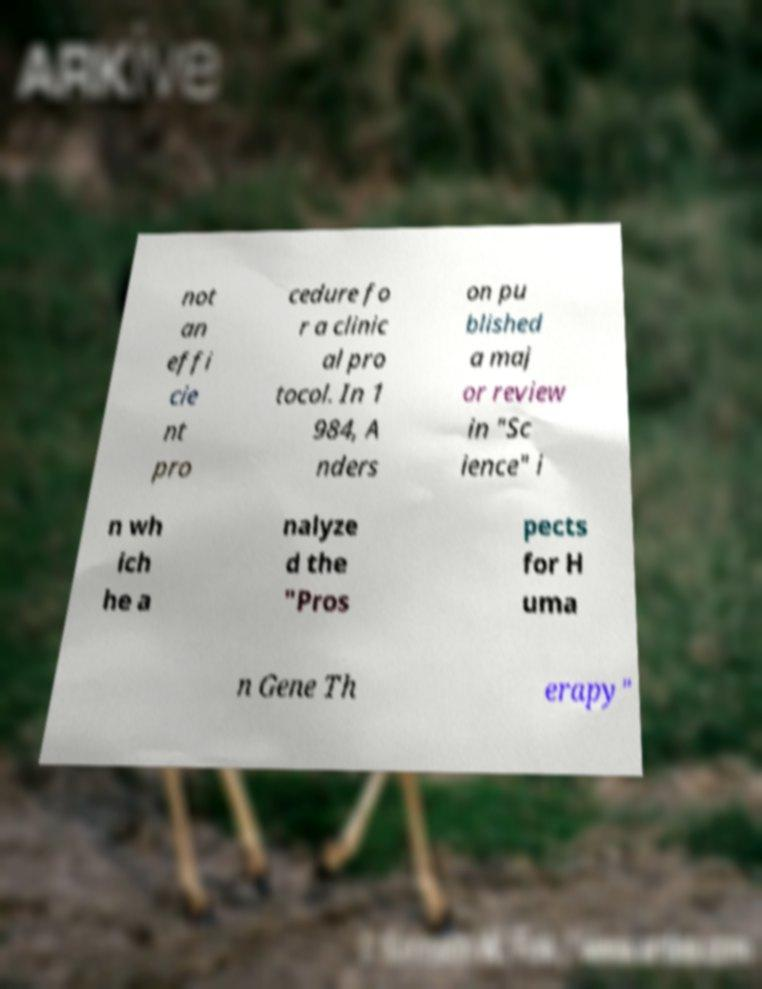There's text embedded in this image that I need extracted. Can you transcribe it verbatim? not an effi cie nt pro cedure fo r a clinic al pro tocol. In 1 984, A nders on pu blished a maj or review in "Sc ience" i n wh ich he a nalyze d the "Pros pects for H uma n Gene Th erapy" 